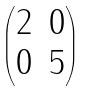Convert formula to latex. <formula><loc_0><loc_0><loc_500><loc_500>\begin{pmatrix} 2 & 0 \\ 0 & 5 \end{pmatrix}</formula> 